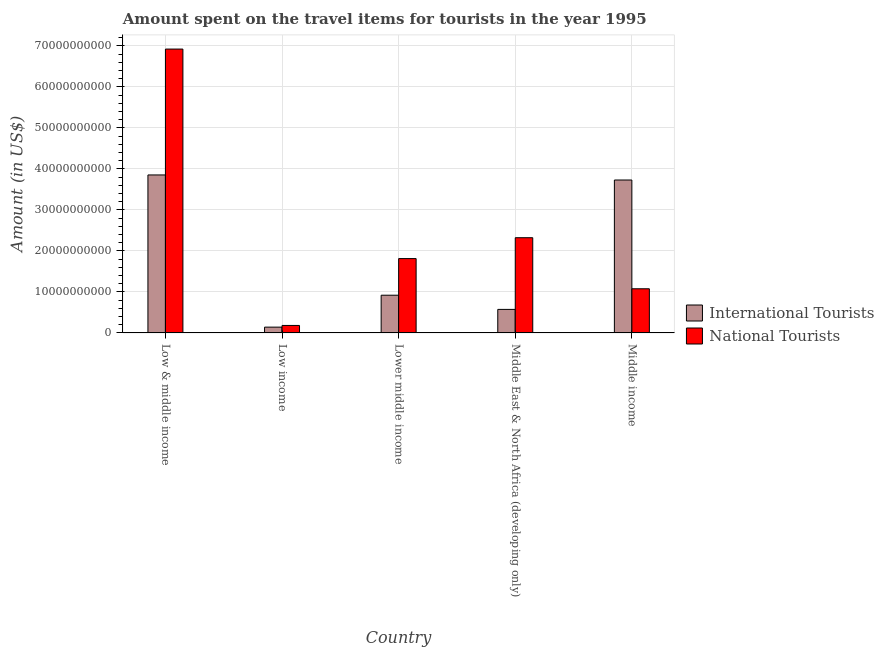How many different coloured bars are there?
Your answer should be very brief. 2. Are the number of bars per tick equal to the number of legend labels?
Your response must be concise. Yes. Are the number of bars on each tick of the X-axis equal?
Provide a succinct answer. Yes. How many bars are there on the 5th tick from the left?
Your answer should be compact. 2. What is the label of the 5th group of bars from the left?
Ensure brevity in your answer.  Middle income. In how many cases, is the number of bars for a given country not equal to the number of legend labels?
Your answer should be compact. 0. What is the amount spent on travel items of international tourists in Low & middle income?
Provide a short and direct response. 3.85e+1. Across all countries, what is the maximum amount spent on travel items of national tourists?
Make the answer very short. 6.92e+1. Across all countries, what is the minimum amount spent on travel items of international tourists?
Ensure brevity in your answer.  1.42e+09. What is the total amount spent on travel items of international tourists in the graph?
Your response must be concise. 9.22e+1. What is the difference between the amount spent on travel items of national tourists in Low & middle income and that in Middle income?
Ensure brevity in your answer.  5.85e+1. What is the difference between the amount spent on travel items of international tourists in Middle income and the amount spent on travel items of national tourists in Low & middle income?
Keep it short and to the point. -3.19e+1. What is the average amount spent on travel items of national tourists per country?
Provide a short and direct response. 2.46e+1. What is the difference between the amount spent on travel items of national tourists and amount spent on travel items of international tourists in Low income?
Give a very brief answer. 4.12e+08. In how many countries, is the amount spent on travel items of national tourists greater than 60000000000 US$?
Your response must be concise. 1. What is the ratio of the amount spent on travel items of international tourists in Low & middle income to that in Lower middle income?
Keep it short and to the point. 4.19. Is the difference between the amount spent on travel items of national tourists in Low & middle income and Low income greater than the difference between the amount spent on travel items of international tourists in Low & middle income and Low income?
Your answer should be very brief. Yes. What is the difference between the highest and the second highest amount spent on travel items of international tourists?
Make the answer very short. 1.24e+09. What is the difference between the highest and the lowest amount spent on travel items of national tourists?
Offer a terse response. 6.74e+1. In how many countries, is the amount spent on travel items of international tourists greater than the average amount spent on travel items of international tourists taken over all countries?
Give a very brief answer. 2. What does the 2nd bar from the left in Lower middle income represents?
Provide a succinct answer. National Tourists. What does the 1st bar from the right in Low income represents?
Make the answer very short. National Tourists. How many countries are there in the graph?
Provide a succinct answer. 5. What is the difference between two consecutive major ticks on the Y-axis?
Offer a terse response. 1.00e+1. Are the values on the major ticks of Y-axis written in scientific E-notation?
Your response must be concise. No. Where does the legend appear in the graph?
Ensure brevity in your answer.  Center right. How are the legend labels stacked?
Ensure brevity in your answer.  Vertical. What is the title of the graph?
Your response must be concise. Amount spent on the travel items for tourists in the year 1995. What is the label or title of the X-axis?
Give a very brief answer. Country. What is the Amount (in US$) of International Tourists in Low & middle income?
Provide a succinct answer. 3.85e+1. What is the Amount (in US$) in National Tourists in Low & middle income?
Your answer should be compact. 6.92e+1. What is the Amount (in US$) of International Tourists in Low income?
Offer a very short reply. 1.42e+09. What is the Amount (in US$) of National Tourists in Low income?
Offer a terse response. 1.83e+09. What is the Amount (in US$) in International Tourists in Lower middle income?
Offer a very short reply. 9.20e+09. What is the Amount (in US$) of National Tourists in Lower middle income?
Ensure brevity in your answer.  1.81e+1. What is the Amount (in US$) of International Tourists in Middle East & North Africa (developing only)?
Provide a short and direct response. 5.74e+09. What is the Amount (in US$) of National Tourists in Middle East & North Africa (developing only)?
Keep it short and to the point. 2.32e+1. What is the Amount (in US$) of International Tourists in Middle income?
Make the answer very short. 3.73e+1. What is the Amount (in US$) of National Tourists in Middle income?
Provide a succinct answer. 1.08e+1. Across all countries, what is the maximum Amount (in US$) of International Tourists?
Keep it short and to the point. 3.85e+1. Across all countries, what is the maximum Amount (in US$) in National Tourists?
Provide a succinct answer. 6.92e+1. Across all countries, what is the minimum Amount (in US$) of International Tourists?
Offer a terse response. 1.42e+09. Across all countries, what is the minimum Amount (in US$) of National Tourists?
Your answer should be very brief. 1.83e+09. What is the total Amount (in US$) of International Tourists in the graph?
Offer a very short reply. 9.22e+1. What is the total Amount (in US$) in National Tourists in the graph?
Your answer should be compact. 1.23e+11. What is the difference between the Amount (in US$) of International Tourists in Low & middle income and that in Low income?
Offer a terse response. 3.71e+1. What is the difference between the Amount (in US$) of National Tourists in Low & middle income and that in Low income?
Your response must be concise. 6.74e+1. What is the difference between the Amount (in US$) in International Tourists in Low & middle income and that in Lower middle income?
Ensure brevity in your answer.  2.93e+1. What is the difference between the Amount (in US$) in National Tourists in Low & middle income and that in Lower middle income?
Ensure brevity in your answer.  5.11e+1. What is the difference between the Amount (in US$) of International Tourists in Low & middle income and that in Middle East & North Africa (developing only)?
Your answer should be compact. 3.28e+1. What is the difference between the Amount (in US$) in National Tourists in Low & middle income and that in Middle East & North Africa (developing only)?
Your answer should be compact. 4.60e+1. What is the difference between the Amount (in US$) of International Tourists in Low & middle income and that in Middle income?
Your response must be concise. 1.24e+09. What is the difference between the Amount (in US$) in National Tourists in Low & middle income and that in Middle income?
Keep it short and to the point. 5.85e+1. What is the difference between the Amount (in US$) in International Tourists in Low income and that in Lower middle income?
Provide a short and direct response. -7.79e+09. What is the difference between the Amount (in US$) in National Tourists in Low income and that in Lower middle income?
Provide a succinct answer. -1.63e+1. What is the difference between the Amount (in US$) in International Tourists in Low income and that in Middle East & North Africa (developing only)?
Your answer should be very brief. -4.32e+09. What is the difference between the Amount (in US$) of National Tourists in Low income and that in Middle East & North Africa (developing only)?
Ensure brevity in your answer.  -2.14e+1. What is the difference between the Amount (in US$) of International Tourists in Low income and that in Middle income?
Ensure brevity in your answer.  -3.59e+1. What is the difference between the Amount (in US$) of National Tourists in Low income and that in Middle income?
Offer a terse response. -8.94e+09. What is the difference between the Amount (in US$) in International Tourists in Lower middle income and that in Middle East & North Africa (developing only)?
Your answer should be compact. 3.46e+09. What is the difference between the Amount (in US$) in National Tourists in Lower middle income and that in Middle East & North Africa (developing only)?
Your answer should be compact. -5.09e+09. What is the difference between the Amount (in US$) of International Tourists in Lower middle income and that in Middle income?
Make the answer very short. -2.81e+1. What is the difference between the Amount (in US$) in National Tourists in Lower middle income and that in Middle income?
Offer a terse response. 7.36e+09. What is the difference between the Amount (in US$) in International Tourists in Middle East & North Africa (developing only) and that in Middle income?
Make the answer very short. -3.16e+1. What is the difference between the Amount (in US$) in National Tourists in Middle East & North Africa (developing only) and that in Middle income?
Give a very brief answer. 1.25e+1. What is the difference between the Amount (in US$) of International Tourists in Low & middle income and the Amount (in US$) of National Tourists in Low income?
Provide a succinct answer. 3.67e+1. What is the difference between the Amount (in US$) in International Tourists in Low & middle income and the Amount (in US$) in National Tourists in Lower middle income?
Offer a very short reply. 2.04e+1. What is the difference between the Amount (in US$) in International Tourists in Low & middle income and the Amount (in US$) in National Tourists in Middle East & North Africa (developing only)?
Provide a succinct answer. 1.53e+1. What is the difference between the Amount (in US$) of International Tourists in Low & middle income and the Amount (in US$) of National Tourists in Middle income?
Ensure brevity in your answer.  2.78e+1. What is the difference between the Amount (in US$) of International Tourists in Low income and the Amount (in US$) of National Tourists in Lower middle income?
Keep it short and to the point. -1.67e+1. What is the difference between the Amount (in US$) in International Tourists in Low income and the Amount (in US$) in National Tourists in Middle East & North Africa (developing only)?
Your response must be concise. -2.18e+1. What is the difference between the Amount (in US$) of International Tourists in Low income and the Amount (in US$) of National Tourists in Middle income?
Provide a succinct answer. -9.35e+09. What is the difference between the Amount (in US$) of International Tourists in Lower middle income and the Amount (in US$) of National Tourists in Middle East & North Africa (developing only)?
Ensure brevity in your answer.  -1.40e+1. What is the difference between the Amount (in US$) of International Tourists in Lower middle income and the Amount (in US$) of National Tourists in Middle income?
Your answer should be compact. -1.57e+09. What is the difference between the Amount (in US$) in International Tourists in Middle East & North Africa (developing only) and the Amount (in US$) in National Tourists in Middle income?
Your answer should be compact. -5.03e+09. What is the average Amount (in US$) in International Tourists per country?
Offer a very short reply. 1.84e+1. What is the average Amount (in US$) of National Tourists per country?
Your answer should be compact. 2.46e+1. What is the difference between the Amount (in US$) of International Tourists and Amount (in US$) of National Tourists in Low & middle income?
Keep it short and to the point. -3.07e+1. What is the difference between the Amount (in US$) of International Tourists and Amount (in US$) of National Tourists in Low income?
Provide a short and direct response. -4.12e+08. What is the difference between the Amount (in US$) of International Tourists and Amount (in US$) of National Tourists in Lower middle income?
Provide a short and direct response. -8.93e+09. What is the difference between the Amount (in US$) in International Tourists and Amount (in US$) in National Tourists in Middle East & North Africa (developing only)?
Your answer should be very brief. -1.75e+1. What is the difference between the Amount (in US$) of International Tourists and Amount (in US$) of National Tourists in Middle income?
Offer a very short reply. 2.65e+1. What is the ratio of the Amount (in US$) of International Tourists in Low & middle income to that in Low income?
Offer a very short reply. 27.18. What is the ratio of the Amount (in US$) of National Tourists in Low & middle income to that in Low income?
Offer a terse response. 37.85. What is the ratio of the Amount (in US$) of International Tourists in Low & middle income to that in Lower middle income?
Keep it short and to the point. 4.19. What is the ratio of the Amount (in US$) of National Tourists in Low & middle income to that in Lower middle income?
Keep it short and to the point. 3.82. What is the ratio of the Amount (in US$) of International Tourists in Low & middle income to that in Middle East & North Africa (developing only)?
Provide a succinct answer. 6.71. What is the ratio of the Amount (in US$) of National Tourists in Low & middle income to that in Middle East & North Africa (developing only)?
Offer a very short reply. 2.98. What is the ratio of the Amount (in US$) of International Tourists in Low & middle income to that in Middle income?
Your answer should be compact. 1.03. What is the ratio of the Amount (in US$) in National Tourists in Low & middle income to that in Middle income?
Provide a succinct answer. 6.43. What is the ratio of the Amount (in US$) of International Tourists in Low income to that in Lower middle income?
Keep it short and to the point. 0.15. What is the ratio of the Amount (in US$) in National Tourists in Low income to that in Lower middle income?
Your answer should be very brief. 0.1. What is the ratio of the Amount (in US$) in International Tourists in Low income to that in Middle East & North Africa (developing only)?
Your answer should be compact. 0.25. What is the ratio of the Amount (in US$) of National Tourists in Low income to that in Middle East & North Africa (developing only)?
Your answer should be compact. 0.08. What is the ratio of the Amount (in US$) of International Tourists in Low income to that in Middle income?
Offer a terse response. 0.04. What is the ratio of the Amount (in US$) in National Tourists in Low income to that in Middle income?
Keep it short and to the point. 0.17. What is the ratio of the Amount (in US$) of International Tourists in Lower middle income to that in Middle East & North Africa (developing only)?
Provide a succinct answer. 1.6. What is the ratio of the Amount (in US$) of National Tourists in Lower middle income to that in Middle East & North Africa (developing only)?
Provide a succinct answer. 0.78. What is the ratio of the Amount (in US$) in International Tourists in Lower middle income to that in Middle income?
Make the answer very short. 0.25. What is the ratio of the Amount (in US$) in National Tourists in Lower middle income to that in Middle income?
Offer a very short reply. 1.68. What is the ratio of the Amount (in US$) of International Tourists in Middle East & North Africa (developing only) to that in Middle income?
Give a very brief answer. 0.15. What is the ratio of the Amount (in US$) in National Tourists in Middle East & North Africa (developing only) to that in Middle income?
Give a very brief answer. 2.16. What is the difference between the highest and the second highest Amount (in US$) in International Tourists?
Ensure brevity in your answer.  1.24e+09. What is the difference between the highest and the second highest Amount (in US$) in National Tourists?
Ensure brevity in your answer.  4.60e+1. What is the difference between the highest and the lowest Amount (in US$) in International Tourists?
Your response must be concise. 3.71e+1. What is the difference between the highest and the lowest Amount (in US$) in National Tourists?
Offer a terse response. 6.74e+1. 